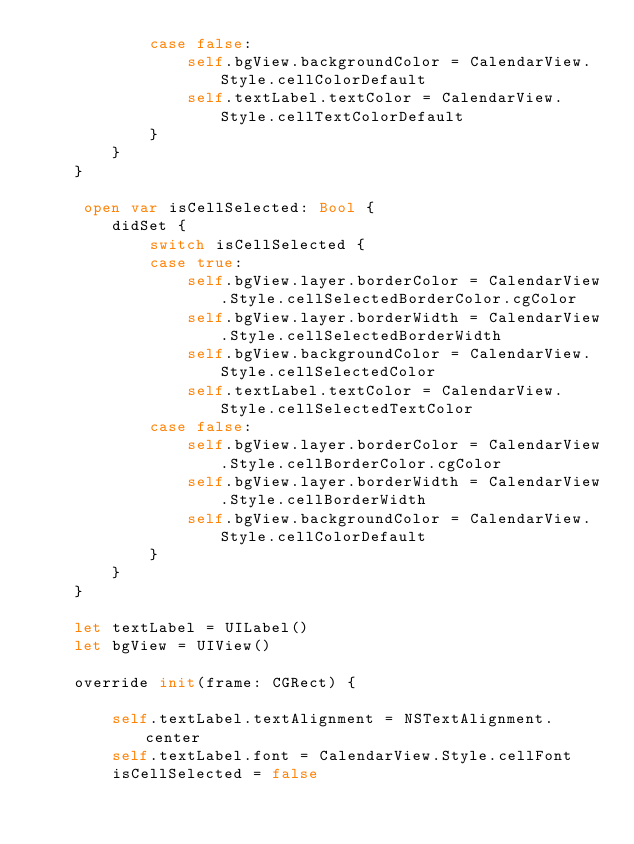Convert code to text. <code><loc_0><loc_0><loc_500><loc_500><_Swift_>            case false:
                self.bgView.backgroundColor = CalendarView.Style.cellColorDefault
                self.textLabel.textColor = CalendarView.Style.cellTextColorDefault
            }
        }
    }

     open var isCellSelected: Bool {
        didSet {
            switch isCellSelected {
            case true:
                self.bgView.layer.borderColor = CalendarView.Style.cellSelectedBorderColor.cgColor
                self.bgView.layer.borderWidth = CalendarView.Style.cellSelectedBorderWidth
                self.bgView.backgroundColor = CalendarView.Style.cellSelectedColor
                self.textLabel.textColor = CalendarView.Style.cellSelectedTextColor
            case false:
                self.bgView.layer.borderColor = CalendarView.Style.cellBorderColor.cgColor
                self.bgView.layer.borderWidth = CalendarView.Style.cellBorderWidth
                self.bgView.backgroundColor = CalendarView.Style.cellColorDefault
            }
        }
    }

    let textLabel = UILabel()
    let bgView = UIView()

    override init(frame: CGRect) {

        self.textLabel.textAlignment = NSTextAlignment.center
        self.textLabel.font = CalendarView.Style.cellFont
        isCellSelected = false
</code> 